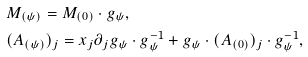<formula> <loc_0><loc_0><loc_500><loc_500>& M _ { ( \psi ) } = M _ { ( 0 ) } \cdot g _ { \psi } , \\ & ( A _ { ( \psi ) } ) _ { j } = x _ { j } \partial _ { j } g _ { \psi } \cdot g _ { \psi } ^ { - 1 } + g _ { \psi } \cdot ( A _ { ( 0 ) } ) _ { j } \cdot g _ { \psi } ^ { - 1 } ,</formula> 